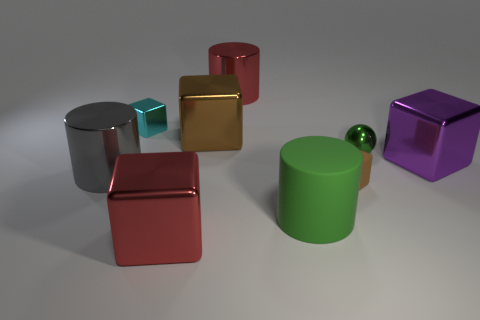Subtract all big shiny cylinders. How many cylinders are left? 1 Add 1 cyan objects. How many objects exist? 10 Subtract all cyan blocks. How many blocks are left? 4 Subtract all blocks. How many objects are left? 4 Subtract 2 cylinders. How many cylinders are left? 1 Subtract all cyan balls. How many green cylinders are left? 1 Subtract all large red metal cylinders. Subtract all big gray shiny objects. How many objects are left? 7 Add 1 large green cylinders. How many large green cylinders are left? 2 Add 5 brown matte cubes. How many brown matte cubes exist? 6 Subtract 0 blue cylinders. How many objects are left? 9 